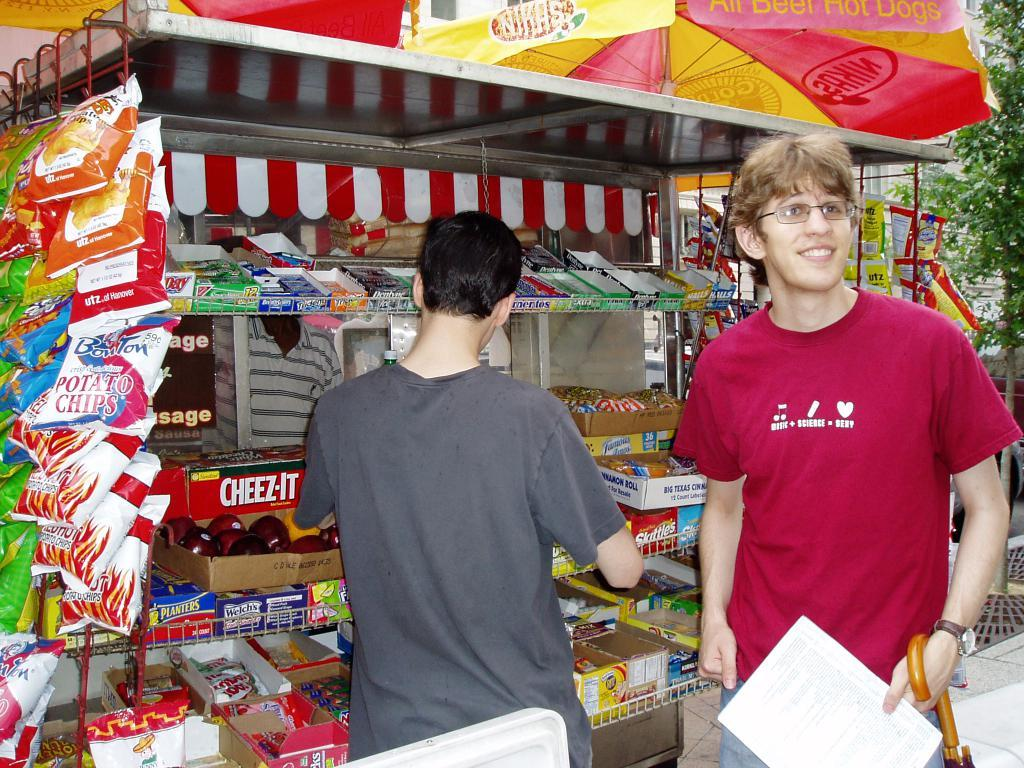<image>
Create a compact narrative representing the image presented. A snack stand selling snacks and Cheez-It and other snacks. 